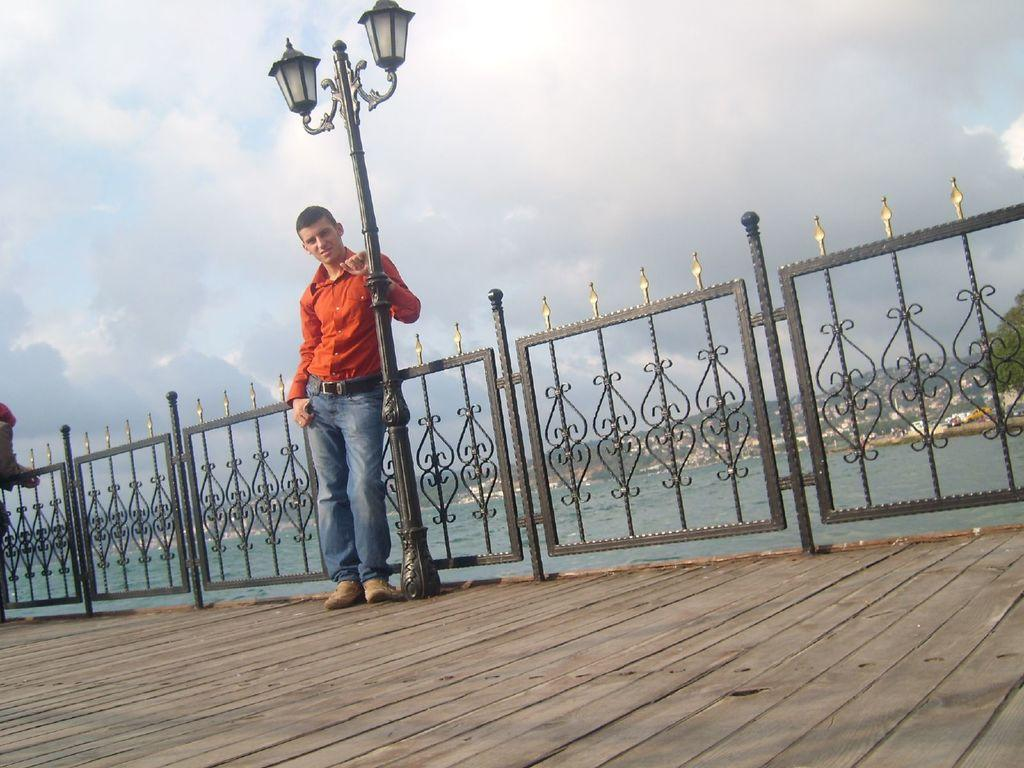What is the main subject of the image? There is a man standing in the image. What can be seen near the man? Lights are present on a pole beside the man. What type of barrier is visible in the image? There is a fence visible in the image. What can be seen in the distance in the image? There is water, a hill, and a tree in the background of the image. What is visible above the hill and tree in the image? The sky is visible in the background of the image. What type of quartz can be seen in the image? There is no quartz present in the image. How does the man react to the shock in the image? There is no shock or reaction to it depicted in the image. 